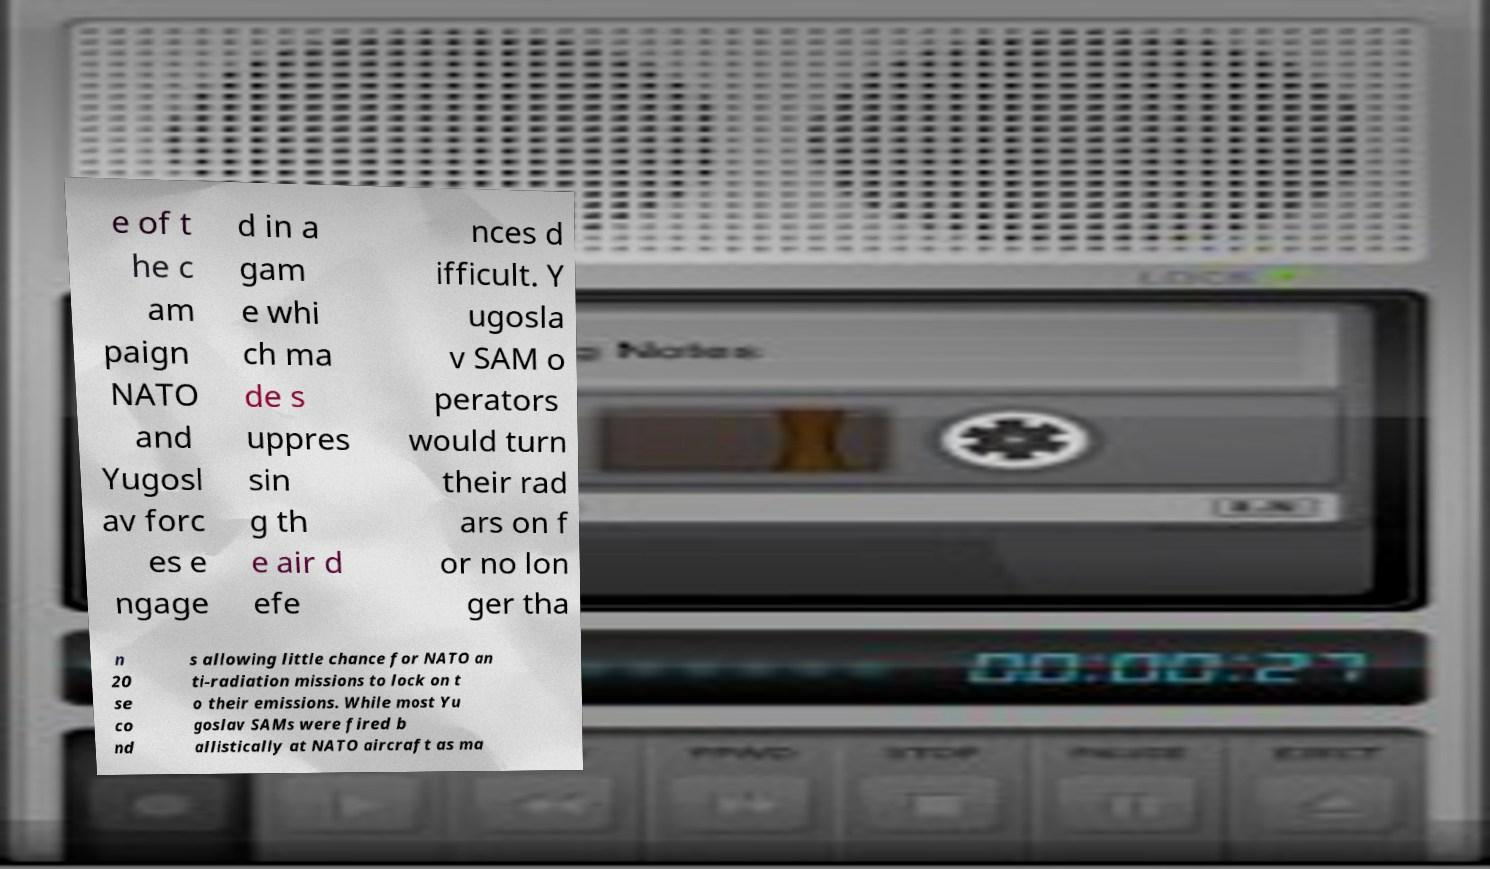There's text embedded in this image that I need extracted. Can you transcribe it verbatim? e of t he c am paign NATO and Yugosl av forc es e ngage d in a gam e whi ch ma de s uppres sin g th e air d efe nces d ifficult. Y ugosla v SAM o perators would turn their rad ars on f or no lon ger tha n 20 se co nd s allowing little chance for NATO an ti-radiation missions to lock on t o their emissions. While most Yu goslav SAMs were fired b allistically at NATO aircraft as ma 